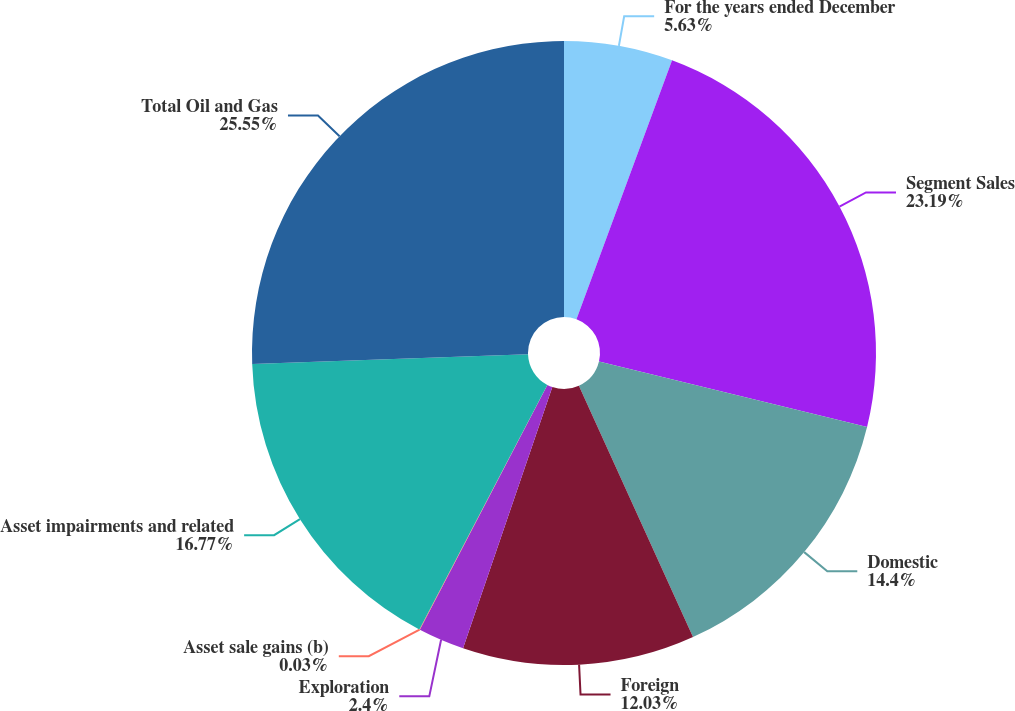Convert chart. <chart><loc_0><loc_0><loc_500><loc_500><pie_chart><fcel>For the years ended December<fcel>Segment Sales<fcel>Domestic<fcel>Foreign<fcel>Exploration<fcel>Asset sale gains (b)<fcel>Asset impairments and related<fcel>Total Oil and Gas<nl><fcel>5.63%<fcel>23.19%<fcel>14.4%<fcel>12.03%<fcel>2.4%<fcel>0.03%<fcel>16.77%<fcel>25.56%<nl></chart> 